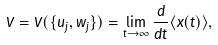<formula> <loc_0><loc_0><loc_500><loc_500>V = V ( \{ u _ { j } , w _ { j } \} ) = \lim _ { t \rightarrow \infty } \frac { d } { d t } \langle x ( t ) \rangle ,</formula> 